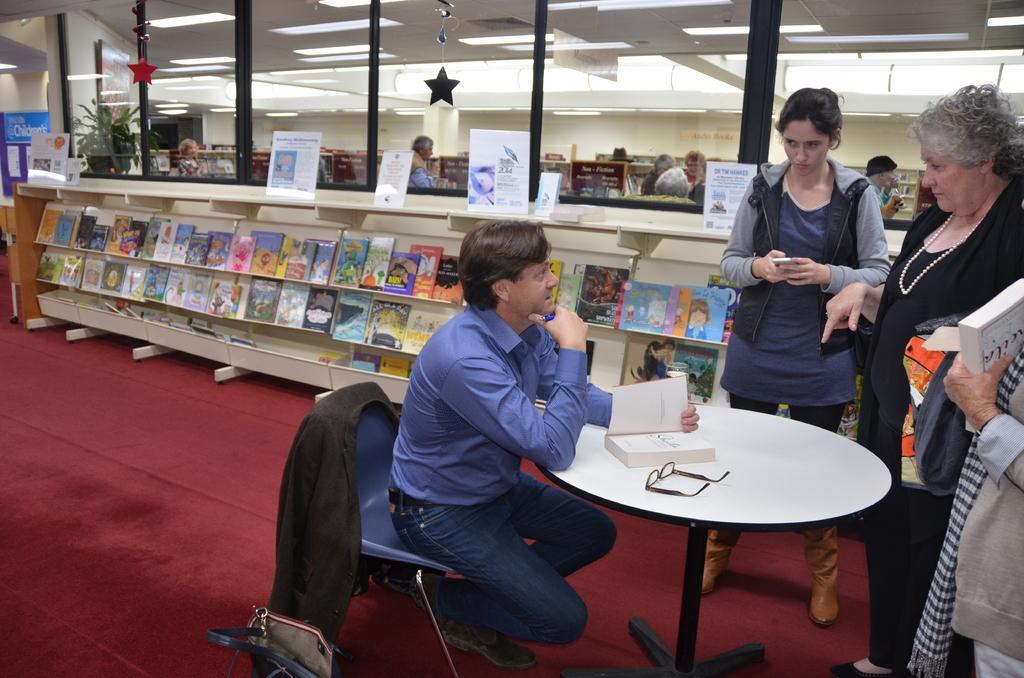Can you describe this image briefly? In this picture we can see a man who is sitting on the chair. This is the table, on the table there is a book, and spectacles. Here we can see some persons standing on the floor. This is the rack, and there are some books in the rack. On the background we can see a wall. And this is the roof. And these are the lights. 